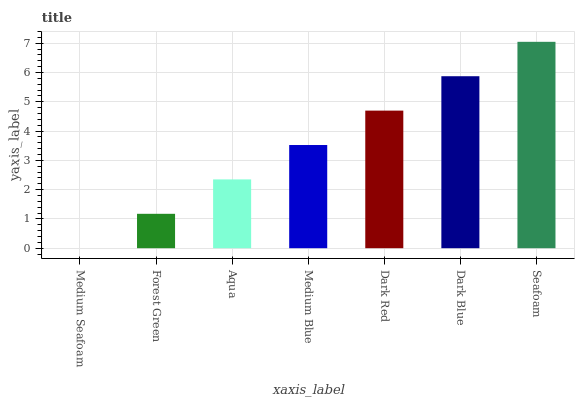Is Medium Seafoam the minimum?
Answer yes or no. Yes. Is Seafoam the maximum?
Answer yes or no. Yes. Is Forest Green the minimum?
Answer yes or no. No. Is Forest Green the maximum?
Answer yes or no. No. Is Forest Green greater than Medium Seafoam?
Answer yes or no. Yes. Is Medium Seafoam less than Forest Green?
Answer yes or no. Yes. Is Medium Seafoam greater than Forest Green?
Answer yes or no. No. Is Forest Green less than Medium Seafoam?
Answer yes or no. No. Is Medium Blue the high median?
Answer yes or no. Yes. Is Medium Blue the low median?
Answer yes or no. Yes. Is Forest Green the high median?
Answer yes or no. No. Is Dark Blue the low median?
Answer yes or no. No. 